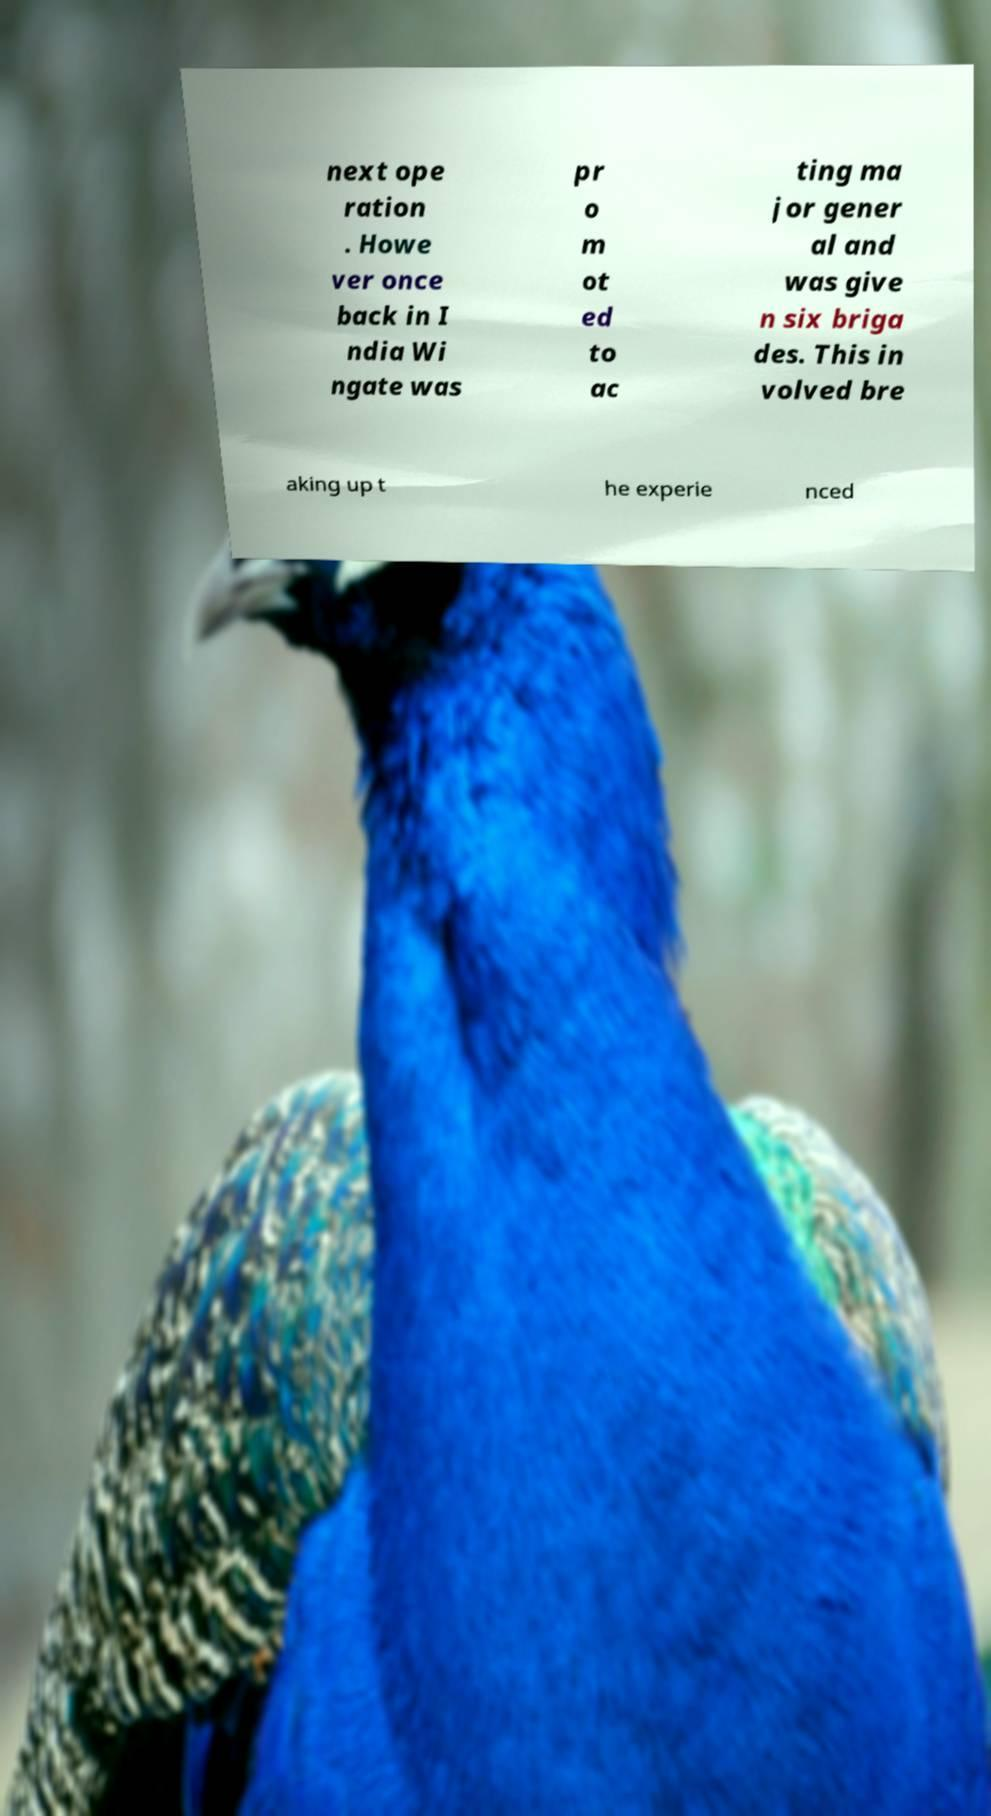Please read and relay the text visible in this image. What does it say? next ope ration . Howe ver once back in I ndia Wi ngate was pr o m ot ed to ac ting ma jor gener al and was give n six briga des. This in volved bre aking up t he experie nced 